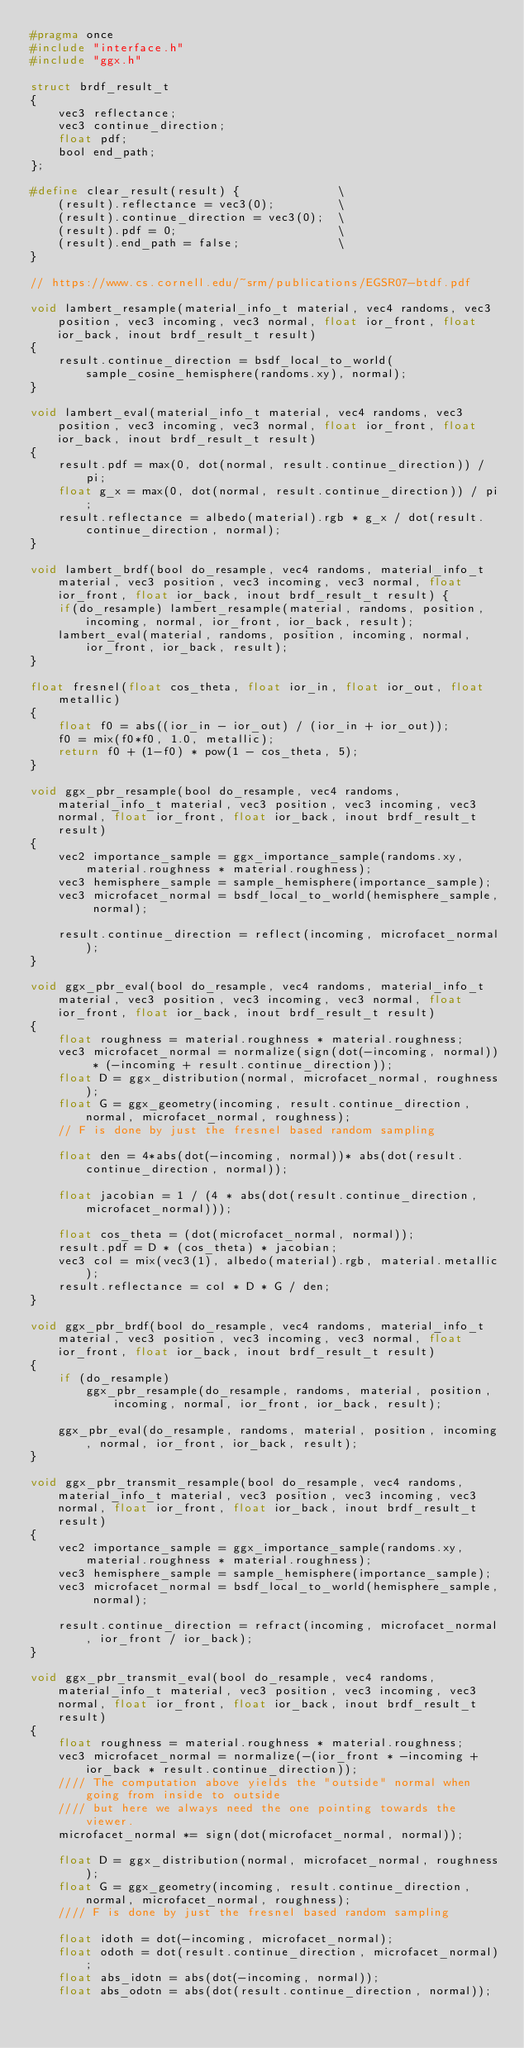Convert code to text. <code><loc_0><loc_0><loc_500><loc_500><_C_>#pragma once
#include "interface.h"
#include "ggx.h"

struct brdf_result_t
{
    vec3 reflectance;
    vec3 continue_direction;
    float pdf;
    bool end_path;
};

#define clear_result(result) {              \
    (result).reflectance = vec3(0);         \
    (result).continue_direction = vec3(0);  \
    (result).pdf = 0;                       \
    (result).end_path = false;              \
}

// https://www.cs.cornell.edu/~srm/publications/EGSR07-btdf.pdf

void lambert_resample(material_info_t material, vec4 randoms, vec3 position, vec3 incoming, vec3 normal, float ior_front, float ior_back, inout brdf_result_t result)
{
    result.continue_direction = bsdf_local_to_world(sample_cosine_hemisphere(randoms.xy), normal);
}

void lambert_eval(material_info_t material, vec4 randoms, vec3 position, vec3 incoming, vec3 normal, float ior_front, float ior_back, inout brdf_result_t result)
{
    result.pdf = max(0, dot(normal, result.continue_direction)) / pi;
    float g_x = max(0, dot(normal, result.continue_direction)) / pi;
    result.reflectance = albedo(material).rgb * g_x / dot(result.continue_direction, normal);
}

void lambert_brdf(bool do_resample, vec4 randoms, material_info_t material, vec3 position, vec3 incoming, vec3 normal, float ior_front, float ior_back, inout brdf_result_t result) {
    if(do_resample) lambert_resample(material, randoms, position, incoming, normal, ior_front, ior_back, result);
    lambert_eval(material, randoms, position, incoming, normal, ior_front, ior_back, result);
}

float fresnel(float cos_theta, float ior_in, float ior_out, float metallic)
{
    float f0 = abs((ior_in - ior_out) / (ior_in + ior_out));
    f0 = mix(f0*f0, 1.0, metallic);
    return f0 + (1-f0) * pow(1 - cos_theta, 5);
}

void ggx_pbr_resample(bool do_resample, vec4 randoms, material_info_t material, vec3 position, vec3 incoming, vec3 normal, float ior_front, float ior_back, inout brdf_result_t result)
{
    vec2 importance_sample = ggx_importance_sample(randoms.xy, material.roughness * material.roughness);
    vec3 hemisphere_sample = sample_hemisphere(importance_sample);
    vec3 microfacet_normal = bsdf_local_to_world(hemisphere_sample, normal);

    result.continue_direction = reflect(incoming, microfacet_normal);
}

void ggx_pbr_eval(bool do_resample, vec4 randoms, material_info_t material, vec3 position, vec3 incoming, vec3 normal, float ior_front, float ior_back, inout brdf_result_t result)
{
    float roughness = material.roughness * material.roughness;
    vec3 microfacet_normal = normalize(sign(dot(-incoming, normal)) * (-incoming + result.continue_direction));
    float D = ggx_distribution(normal, microfacet_normal, roughness);
    float G = ggx_geometry(incoming, result.continue_direction, normal, microfacet_normal, roughness);
    // F is done by just the fresnel based random sampling

    float den = 4*abs(dot(-incoming, normal))* abs(dot(result.continue_direction, normal));

    float jacobian = 1 / (4 * abs(dot(result.continue_direction, microfacet_normal)));

    float cos_theta = (dot(microfacet_normal, normal));
    result.pdf = D * (cos_theta) * jacobian;
    vec3 col = mix(vec3(1), albedo(material).rgb, material.metallic);
    result.reflectance = col * D * G / den;
}

void ggx_pbr_brdf(bool do_resample, vec4 randoms, material_info_t material, vec3 position, vec3 incoming, vec3 normal, float ior_front, float ior_back, inout brdf_result_t result)
{
    if (do_resample)
        ggx_pbr_resample(do_resample, randoms, material, position, incoming, normal, ior_front, ior_back, result);

    ggx_pbr_eval(do_resample, randoms, material, position, incoming, normal, ior_front, ior_back, result);
}

void ggx_pbr_transmit_resample(bool do_resample, vec4 randoms, material_info_t material, vec3 position, vec3 incoming, vec3 normal, float ior_front, float ior_back, inout brdf_result_t result)
{
    vec2 importance_sample = ggx_importance_sample(randoms.xy, material.roughness * material.roughness);
    vec3 hemisphere_sample = sample_hemisphere(importance_sample);
    vec3 microfacet_normal = bsdf_local_to_world(hemisphere_sample, normal);

    result.continue_direction = refract(incoming, microfacet_normal, ior_front / ior_back);
}

void ggx_pbr_transmit_eval(bool do_resample, vec4 randoms, material_info_t material, vec3 position, vec3 incoming, vec3 normal, float ior_front, float ior_back, inout brdf_result_t result)
{
    float roughness = material.roughness * material.roughness;
    vec3 microfacet_normal = normalize(-(ior_front * -incoming + ior_back * result.continue_direction));
    //// The computation above yields the "outside" normal when going from inside to outside 
    //// but here we always need the one pointing towards the viewer.
    microfacet_normal *= sign(dot(microfacet_normal, normal));

    float D = ggx_distribution(normal, microfacet_normal, roughness);
    float G = ggx_geometry(incoming, result.continue_direction, normal, microfacet_normal, roughness);
    //// F is done by just the fresnel based random sampling

    float idoth = dot(-incoming, microfacet_normal);
    float odoth = dot(result.continue_direction, microfacet_normal);
    float abs_idotn = abs(dot(-incoming, normal));
    float abs_odotn = abs(dot(result.continue_direction, normal));
</code> 